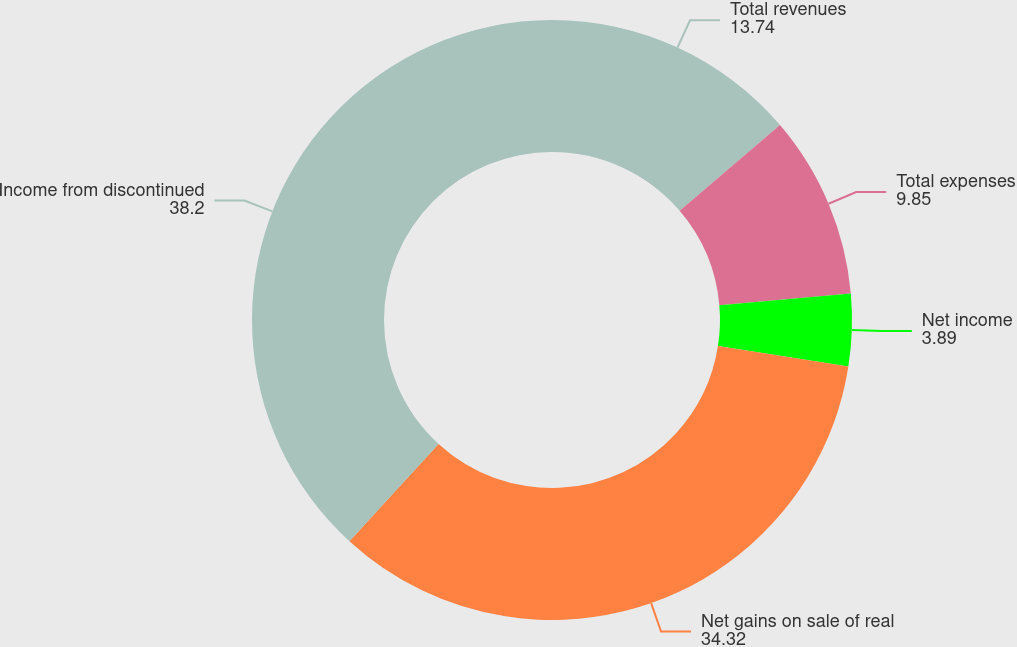Convert chart to OTSL. <chart><loc_0><loc_0><loc_500><loc_500><pie_chart><fcel>Total revenues<fcel>Total expenses<fcel>Net income<fcel>Net gains on sale of real<fcel>Income from discontinued<nl><fcel>13.74%<fcel>9.85%<fcel>3.89%<fcel>34.32%<fcel>38.2%<nl></chart> 